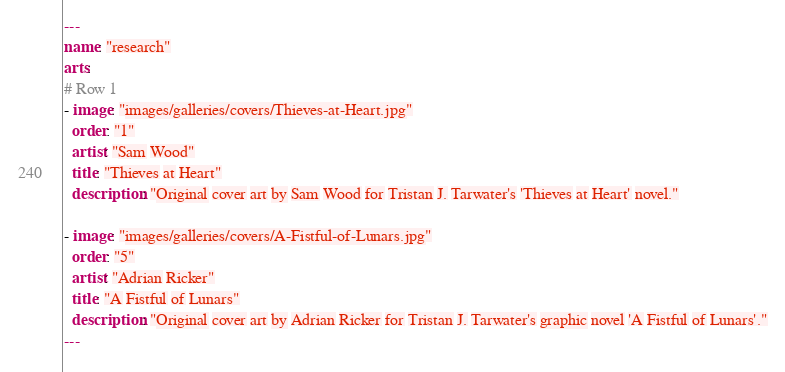Convert code to text. <code><loc_0><loc_0><loc_500><loc_500><_YAML_>---
name: "research"
arts:
# Row 1
- image: "images/galleries/covers/Thieves-at-Heart.jpg"
  order: "1"
  artist: "Sam Wood"
  title: "Thieves at Heart"
  description: "Original cover art by Sam Wood for Tristan J. Tarwater's 'Thieves at Heart' novel."
  
- image: "images/galleries/covers/A-Fistful-of-Lunars.jpg"
  order: "5"
  artist: "Adrian Ricker"
  title: "A Fistful of Lunars"
  description: "Original cover art by Adrian Ricker for Tristan J. Tarwater's graphic novel 'A Fistful of Lunars'."
---
</code> 